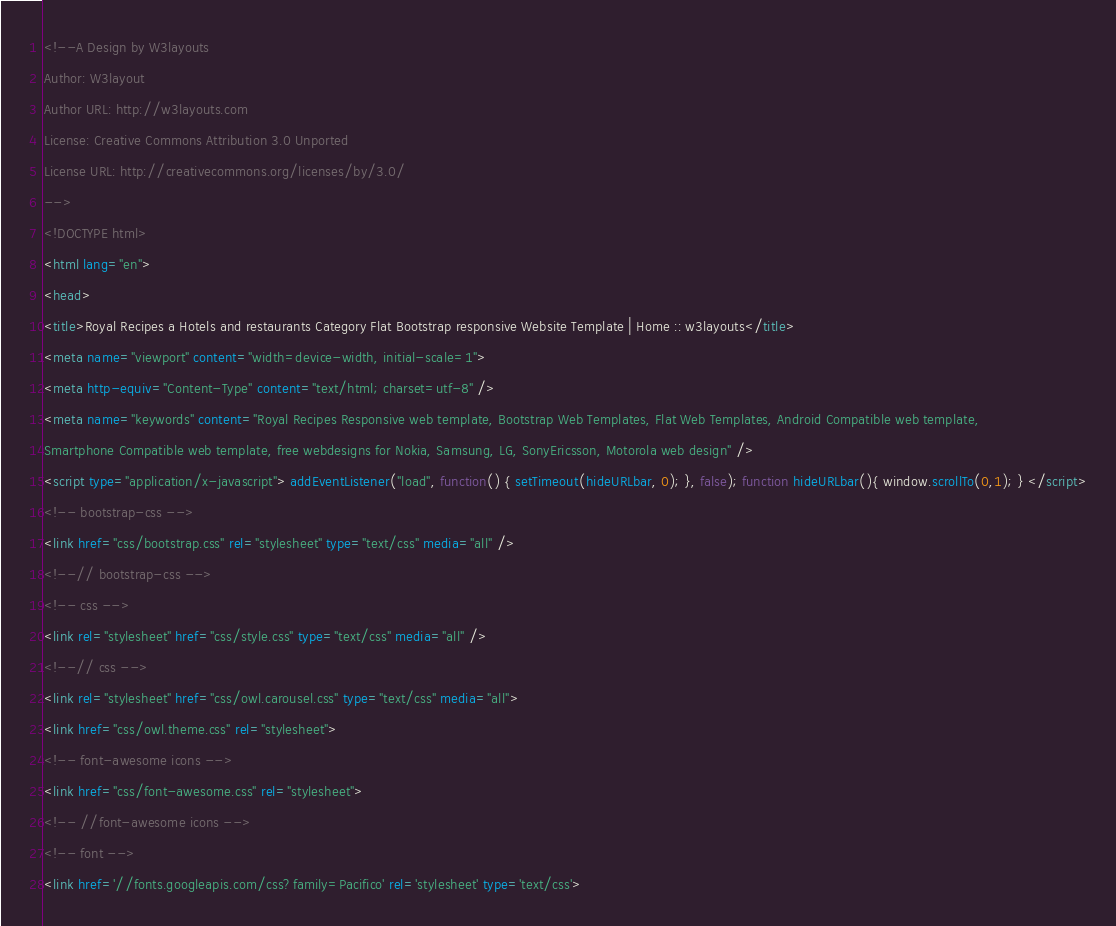Convert code to text. <code><loc_0><loc_0><loc_500><loc_500><_HTML_><!--A Design by W3layouts
Author: W3layout
Author URL: http://w3layouts.com
License: Creative Commons Attribution 3.0 Unported
License URL: http://creativecommons.org/licenses/by/3.0/
-->
<!DOCTYPE html>
<html lang="en">
<head>
<title>Royal Recipes a Hotels and restaurants Category Flat Bootstrap responsive Website Template | Home :: w3layouts</title>
<meta name="viewport" content="width=device-width, initial-scale=1">
<meta http-equiv="Content-Type" content="text/html; charset=utf-8" />
<meta name="keywords" content="Royal Recipes Responsive web template, Bootstrap Web Templates, Flat Web Templates, Android Compatible web template, 
Smartphone Compatible web template, free webdesigns for Nokia, Samsung, LG, SonyEricsson, Motorola web design" />
<script type="application/x-javascript"> addEventListener("load", function() { setTimeout(hideURLbar, 0); }, false); function hideURLbar(){ window.scrollTo(0,1); } </script>
<!-- bootstrap-css -->
<link href="css/bootstrap.css" rel="stylesheet" type="text/css" media="all" />
<!--// bootstrap-css -->
<!-- css -->
<link rel="stylesheet" href="css/style.css" type="text/css" media="all" />
<!--// css -->
<link rel="stylesheet" href="css/owl.carousel.css" type="text/css" media="all">
<link href="css/owl.theme.css" rel="stylesheet">
<!-- font-awesome icons -->
<link href="css/font-awesome.css" rel="stylesheet"> 
<!-- //font-awesome icons -->
<!-- font -->
<link href='//fonts.googleapis.com/css?family=Pacifico' rel='stylesheet' type='text/css'></code> 